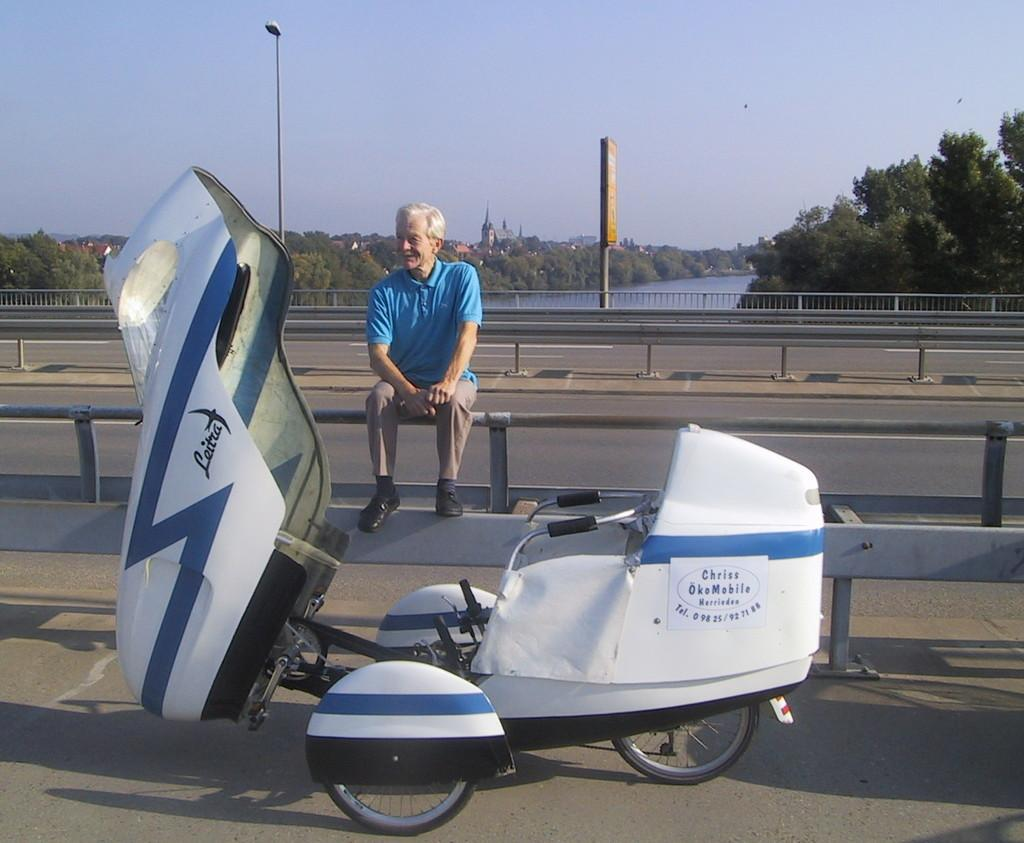<image>
Offer a succinct explanation of the picture presented. A man sits on a railing next to a vehicle with the words Chriss OkoMobile on the side of it. 